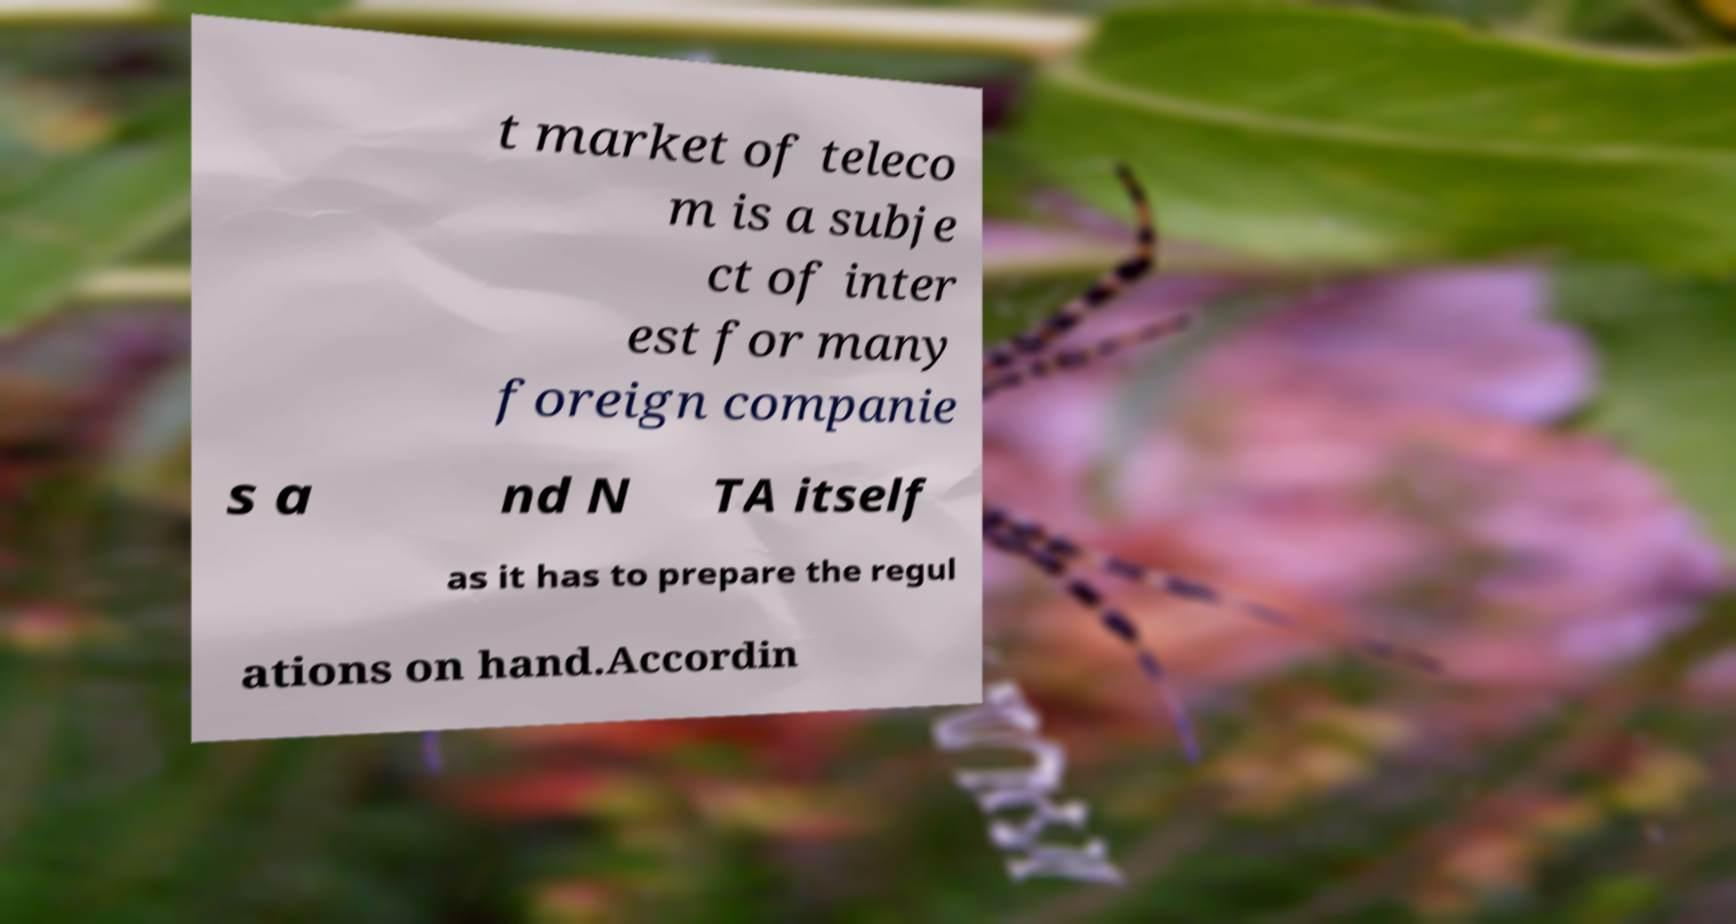Can you accurately transcribe the text from the provided image for me? t market of teleco m is a subje ct of inter est for many foreign companie s a nd N TA itself as it has to prepare the regul ations on hand.Accordin 